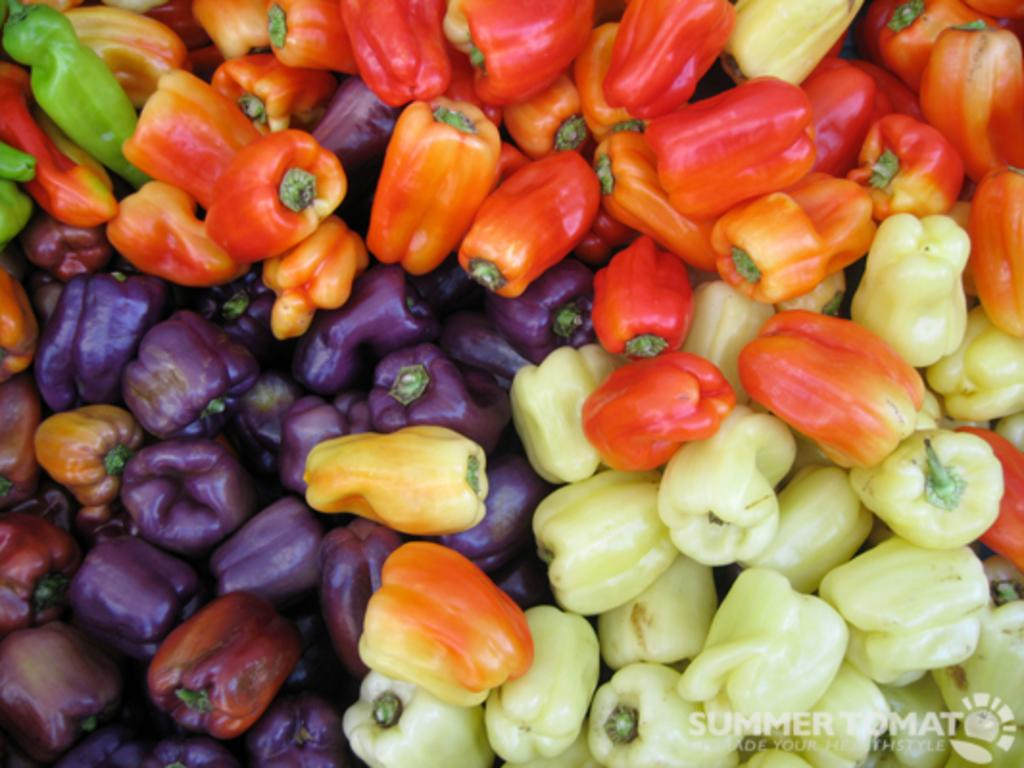What types of capsicums can be seen in the image? There are red, violet, light green, and dark green capsicums in the image. Is there any text present in the image? Yes, there is a text in the image. Where might this image have been taken? The image may have been taken in a market. At what time of day might this image have been taken? The image may have been taken during the day. What type of flesh can be seen in the image? There is no flesh visible in the image; it features capsicums and text. Can you describe the canvas on which the image is painted? The image is not a painting, so there is no canvas present. 